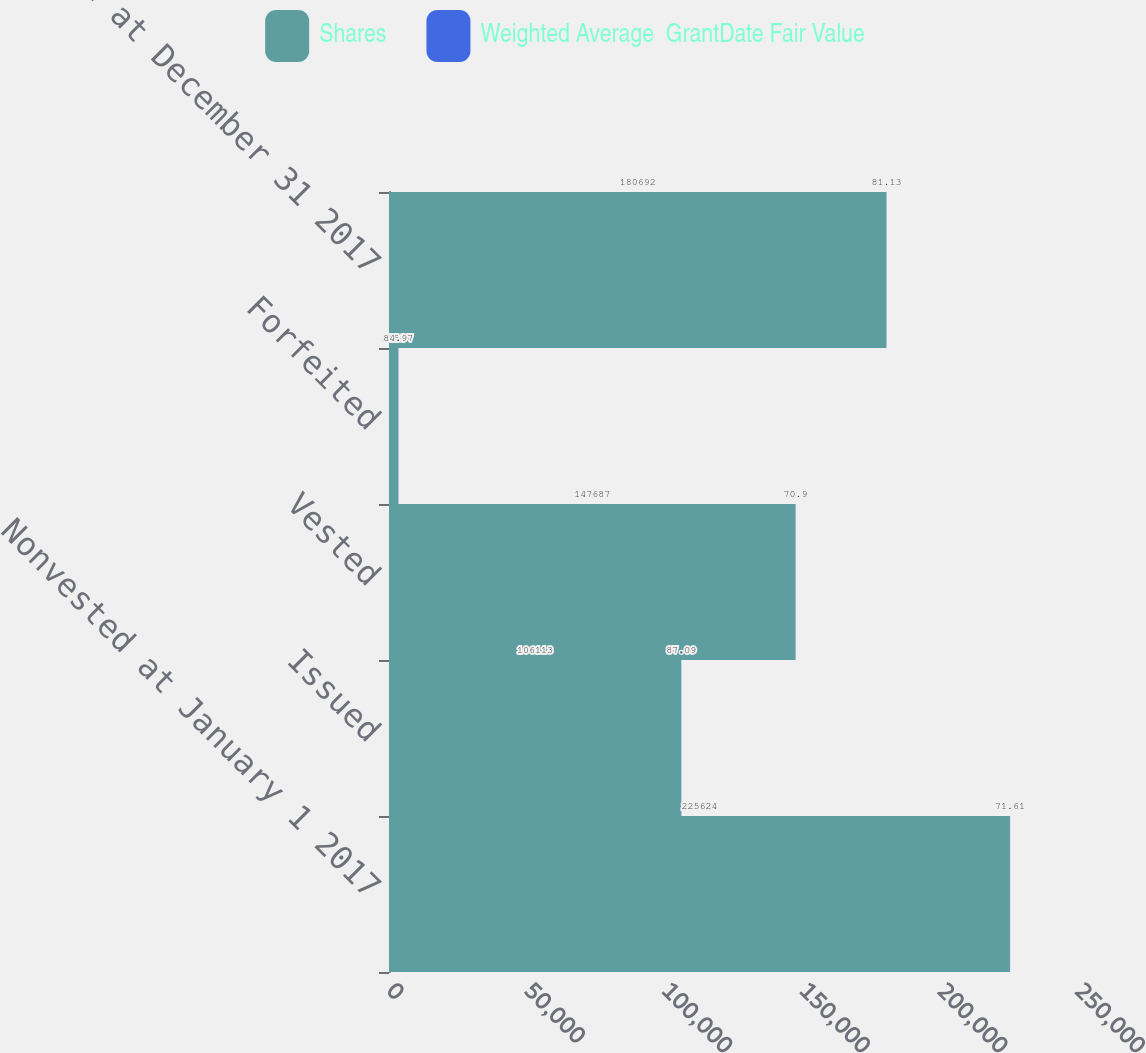Convert chart to OTSL. <chart><loc_0><loc_0><loc_500><loc_500><stacked_bar_chart><ecel><fcel>Nonvested at January 1 2017<fcel>Issued<fcel>Vested<fcel>Forfeited<fcel>Nonvested at December 31 2017<nl><fcel>Shares<fcel>225624<fcel>106113<fcel>147687<fcel>3358<fcel>180692<nl><fcel>Weighted Average  GrantDate Fair Value<fcel>71.61<fcel>87.09<fcel>70.9<fcel>84.97<fcel>81.13<nl></chart> 